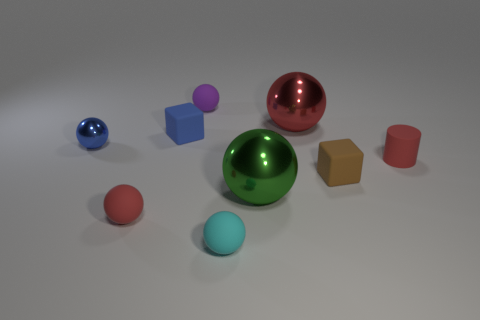Subtract all cyan rubber balls. How many balls are left? 5 Subtract all green spheres. How many spheres are left? 5 Subtract all blue spheres. Subtract all purple cylinders. How many spheres are left? 5 Add 1 tiny purple rubber objects. How many objects exist? 10 Subtract all spheres. How many objects are left? 3 Add 8 cyan spheres. How many cyan spheres are left? 9 Add 7 metal balls. How many metal balls exist? 10 Subtract 0 yellow cubes. How many objects are left? 9 Subtract all cyan things. Subtract all tiny purple balls. How many objects are left? 7 